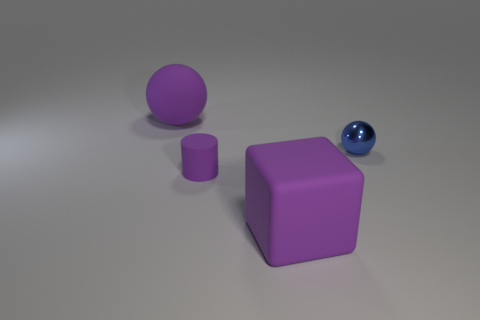There is a large sphere that is the same color as the cube; what is its material?
Your answer should be compact. Rubber. The ball to the left of the large purple matte block is what color?
Offer a very short reply. Purple. Is the color of the tiny metallic sphere the same as the matte block?
Provide a short and direct response. No. How many tiny balls are behind the large purple thing that is to the right of the big purple object that is behind the blue sphere?
Your response must be concise. 1. What is the size of the purple matte ball?
Offer a very short reply. Large. There is a purple ball that is the same size as the purple matte block; what is it made of?
Offer a terse response. Rubber. There is a large sphere; how many matte objects are in front of it?
Your answer should be compact. 2. Are the big object to the right of the tiny purple rubber thing and the tiny object to the left of the blue shiny thing made of the same material?
Your answer should be very brief. Yes. There is a tiny object that is to the left of the large thing that is in front of the big purple rubber thing to the left of the big purple rubber cube; what is its shape?
Provide a short and direct response. Cylinder. What is the shape of the tiny purple object?
Ensure brevity in your answer.  Cylinder. 